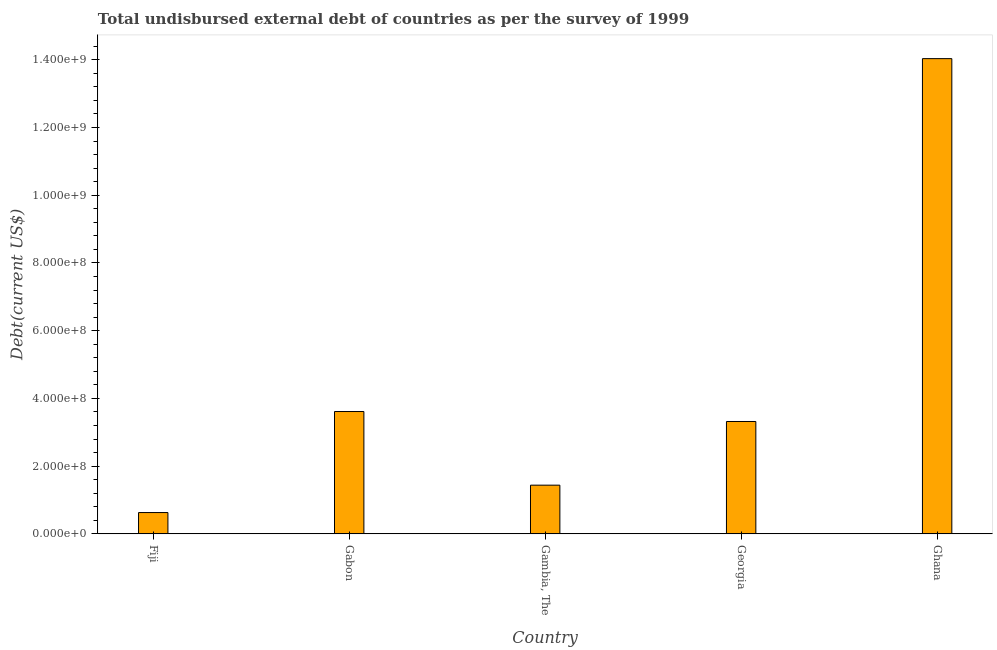Does the graph contain any zero values?
Your answer should be compact. No. What is the title of the graph?
Offer a terse response. Total undisbursed external debt of countries as per the survey of 1999. What is the label or title of the Y-axis?
Make the answer very short. Debt(current US$). What is the total debt in Gabon?
Your answer should be compact. 3.61e+08. Across all countries, what is the maximum total debt?
Make the answer very short. 1.40e+09. Across all countries, what is the minimum total debt?
Your answer should be compact. 6.29e+07. In which country was the total debt maximum?
Offer a terse response. Ghana. In which country was the total debt minimum?
Provide a short and direct response. Fiji. What is the sum of the total debt?
Keep it short and to the point. 2.30e+09. What is the difference between the total debt in Fiji and Ghana?
Your answer should be compact. -1.34e+09. What is the average total debt per country?
Your answer should be very brief. 4.61e+08. What is the median total debt?
Provide a succinct answer. 3.32e+08. In how many countries, is the total debt greater than 1040000000 US$?
Make the answer very short. 1. What is the ratio of the total debt in Fiji to that in Gambia, The?
Your answer should be compact. 0.44. What is the difference between the highest and the second highest total debt?
Give a very brief answer. 1.04e+09. Is the sum of the total debt in Gabon and Ghana greater than the maximum total debt across all countries?
Give a very brief answer. Yes. What is the difference between the highest and the lowest total debt?
Your answer should be compact. 1.34e+09. Are all the bars in the graph horizontal?
Offer a very short reply. No. What is the difference between two consecutive major ticks on the Y-axis?
Offer a very short reply. 2.00e+08. Are the values on the major ticks of Y-axis written in scientific E-notation?
Keep it short and to the point. Yes. What is the Debt(current US$) in Fiji?
Your response must be concise. 6.29e+07. What is the Debt(current US$) of Gabon?
Your response must be concise. 3.61e+08. What is the Debt(current US$) of Gambia, The?
Provide a succinct answer. 1.44e+08. What is the Debt(current US$) in Georgia?
Provide a short and direct response. 3.32e+08. What is the Debt(current US$) of Ghana?
Keep it short and to the point. 1.40e+09. What is the difference between the Debt(current US$) in Fiji and Gabon?
Your answer should be compact. -2.98e+08. What is the difference between the Debt(current US$) in Fiji and Gambia, The?
Offer a very short reply. -8.09e+07. What is the difference between the Debt(current US$) in Fiji and Georgia?
Your answer should be very brief. -2.69e+08. What is the difference between the Debt(current US$) in Fiji and Ghana?
Offer a very short reply. -1.34e+09. What is the difference between the Debt(current US$) in Gabon and Gambia, The?
Your answer should be compact. 2.17e+08. What is the difference between the Debt(current US$) in Gabon and Georgia?
Your answer should be very brief. 2.95e+07. What is the difference between the Debt(current US$) in Gabon and Ghana?
Make the answer very short. -1.04e+09. What is the difference between the Debt(current US$) in Gambia, The and Georgia?
Ensure brevity in your answer.  -1.88e+08. What is the difference between the Debt(current US$) in Gambia, The and Ghana?
Ensure brevity in your answer.  -1.26e+09. What is the difference between the Debt(current US$) in Georgia and Ghana?
Provide a short and direct response. -1.07e+09. What is the ratio of the Debt(current US$) in Fiji to that in Gabon?
Make the answer very short. 0.17. What is the ratio of the Debt(current US$) in Fiji to that in Gambia, The?
Provide a short and direct response. 0.44. What is the ratio of the Debt(current US$) in Fiji to that in Georgia?
Provide a short and direct response. 0.19. What is the ratio of the Debt(current US$) in Fiji to that in Ghana?
Your response must be concise. 0.04. What is the ratio of the Debt(current US$) in Gabon to that in Gambia, The?
Offer a very short reply. 2.51. What is the ratio of the Debt(current US$) in Gabon to that in Georgia?
Offer a very short reply. 1.09. What is the ratio of the Debt(current US$) in Gabon to that in Ghana?
Your answer should be very brief. 0.26. What is the ratio of the Debt(current US$) in Gambia, The to that in Georgia?
Make the answer very short. 0.43. What is the ratio of the Debt(current US$) in Gambia, The to that in Ghana?
Your answer should be compact. 0.1. What is the ratio of the Debt(current US$) in Georgia to that in Ghana?
Offer a terse response. 0.24. 